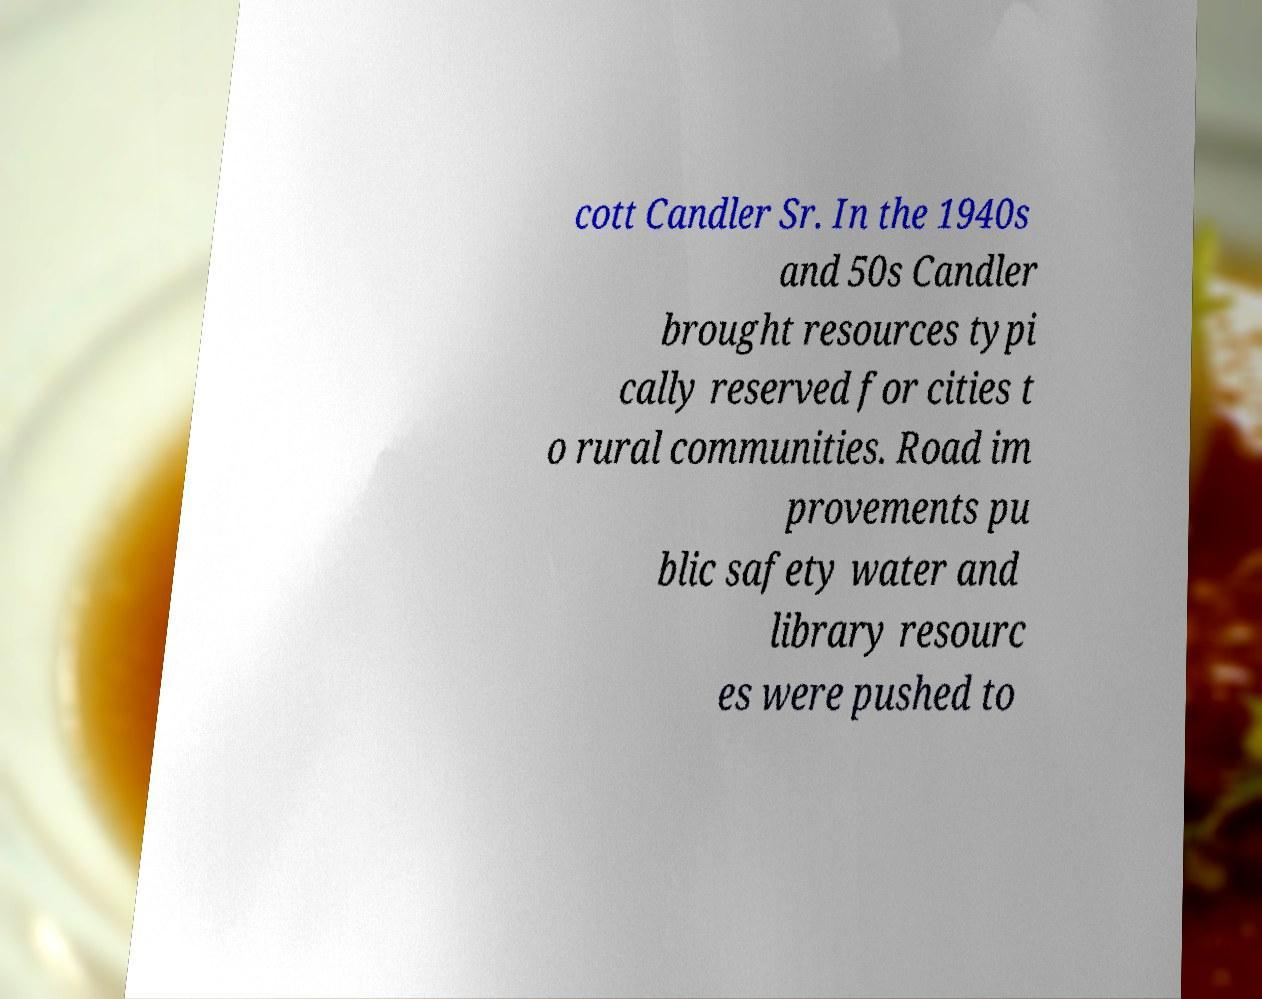There's text embedded in this image that I need extracted. Can you transcribe it verbatim? cott Candler Sr. In the 1940s and 50s Candler brought resources typi cally reserved for cities t o rural communities. Road im provements pu blic safety water and library resourc es were pushed to 